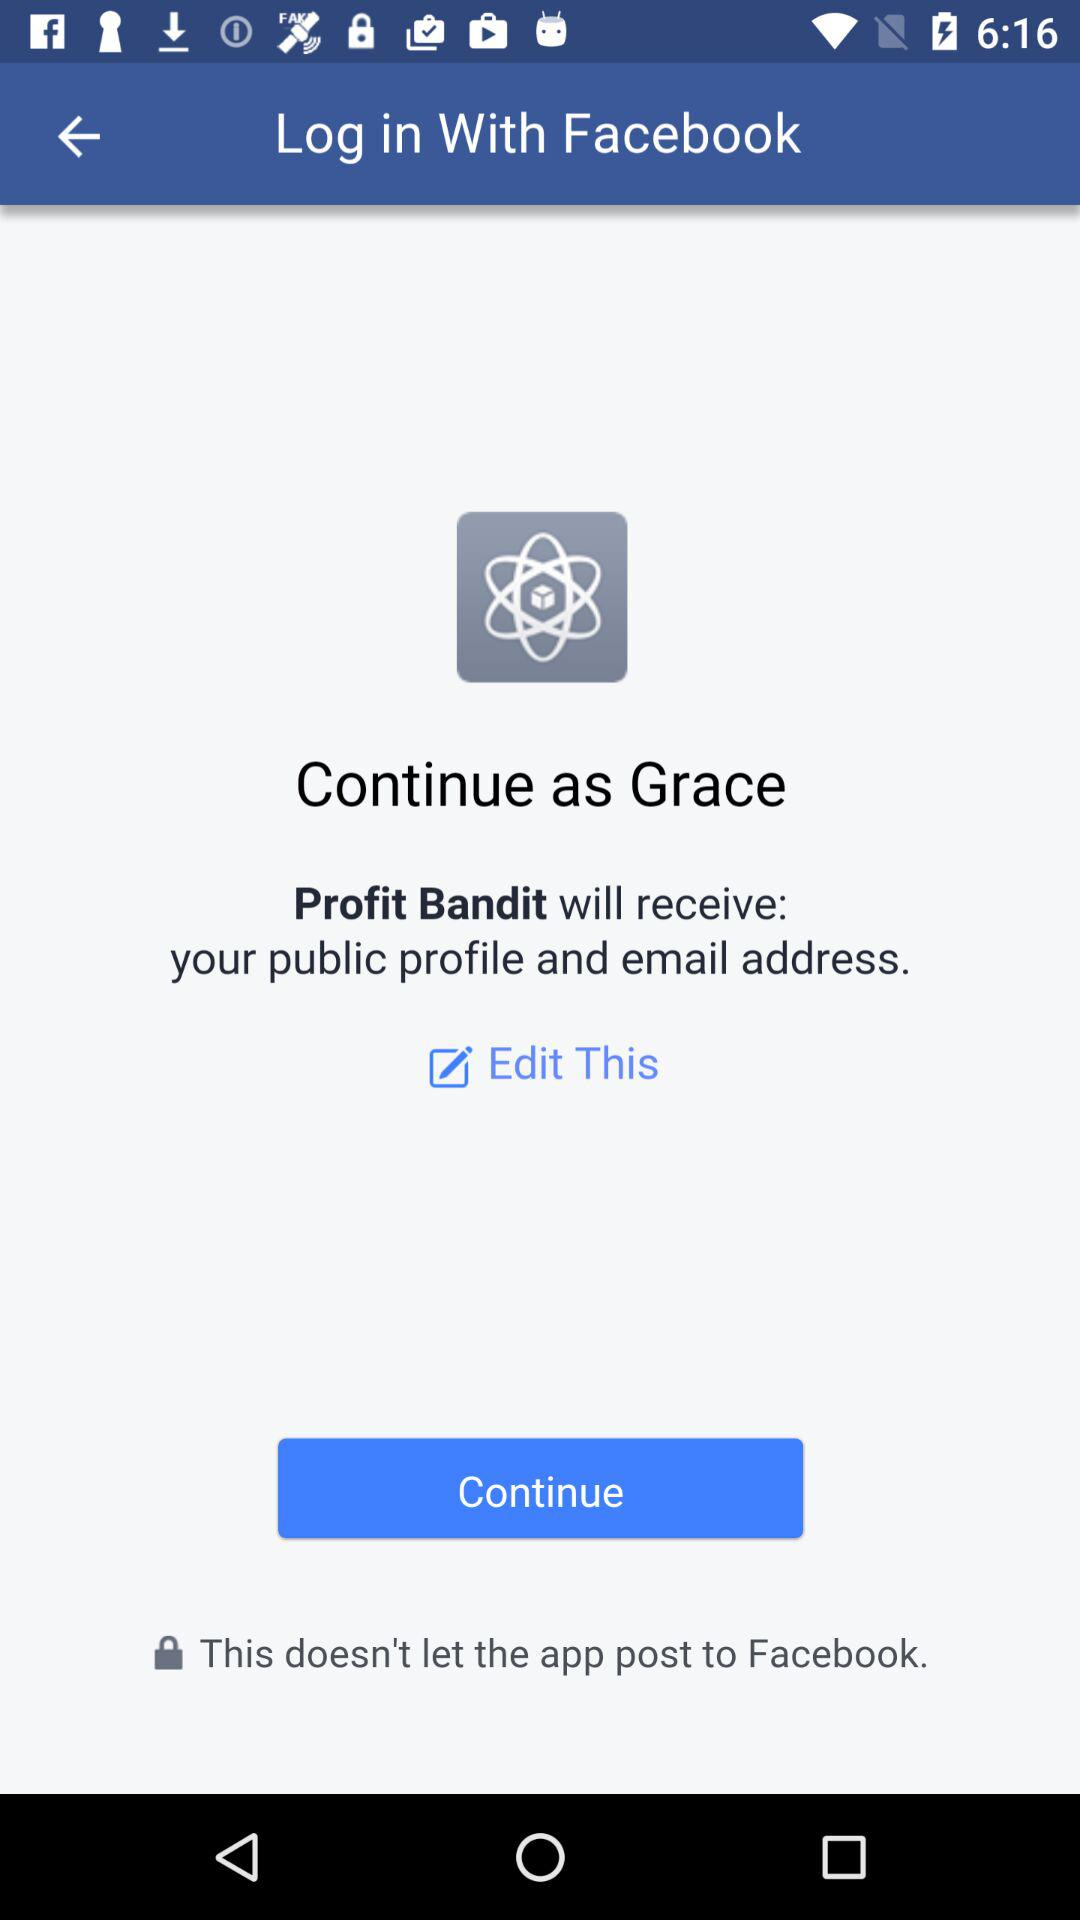What application will receive your public profile and email address? The application that will receive your public profile and email address is "Profit Bandit". 